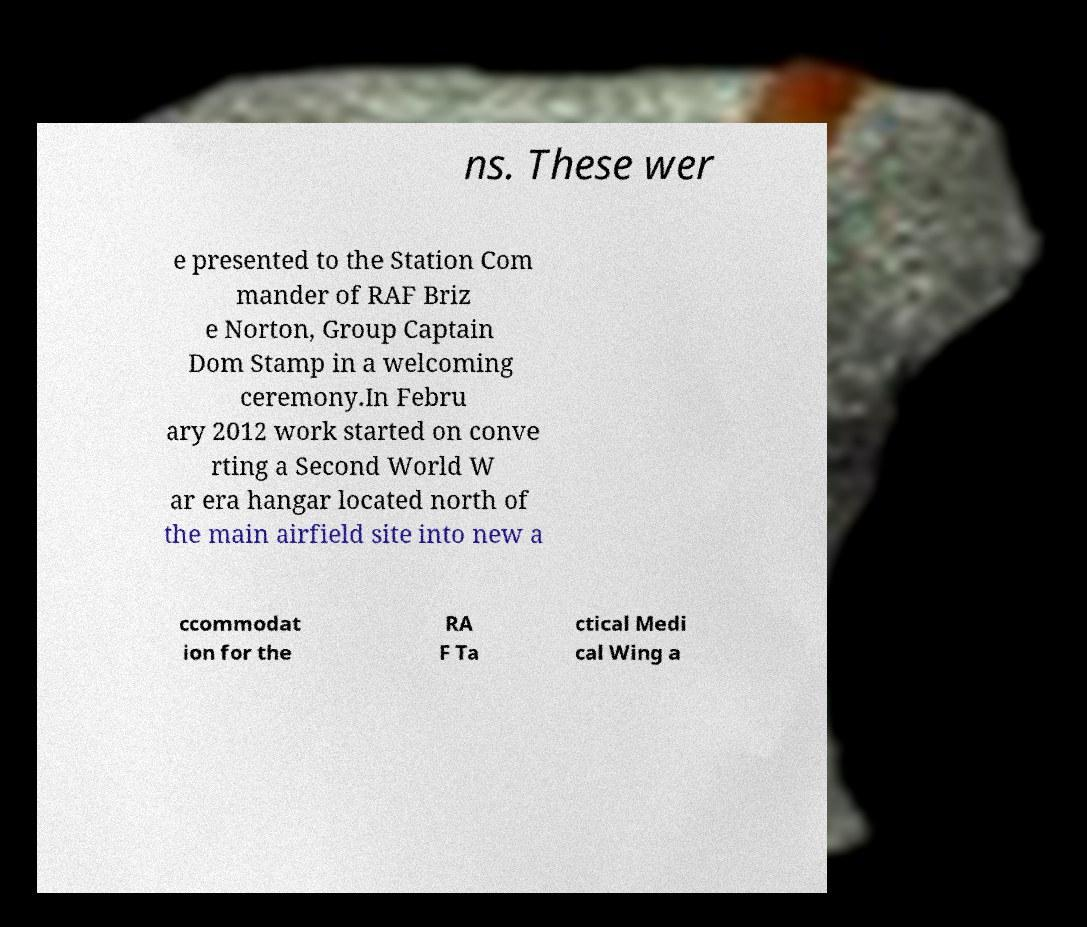Please identify and transcribe the text found in this image. ns. These wer e presented to the Station Com mander of RAF Briz e Norton, Group Captain Dom Stamp in a welcoming ceremony.In Febru ary 2012 work started on conve rting a Second World W ar era hangar located north of the main airfield site into new a ccommodat ion for the RA F Ta ctical Medi cal Wing a 